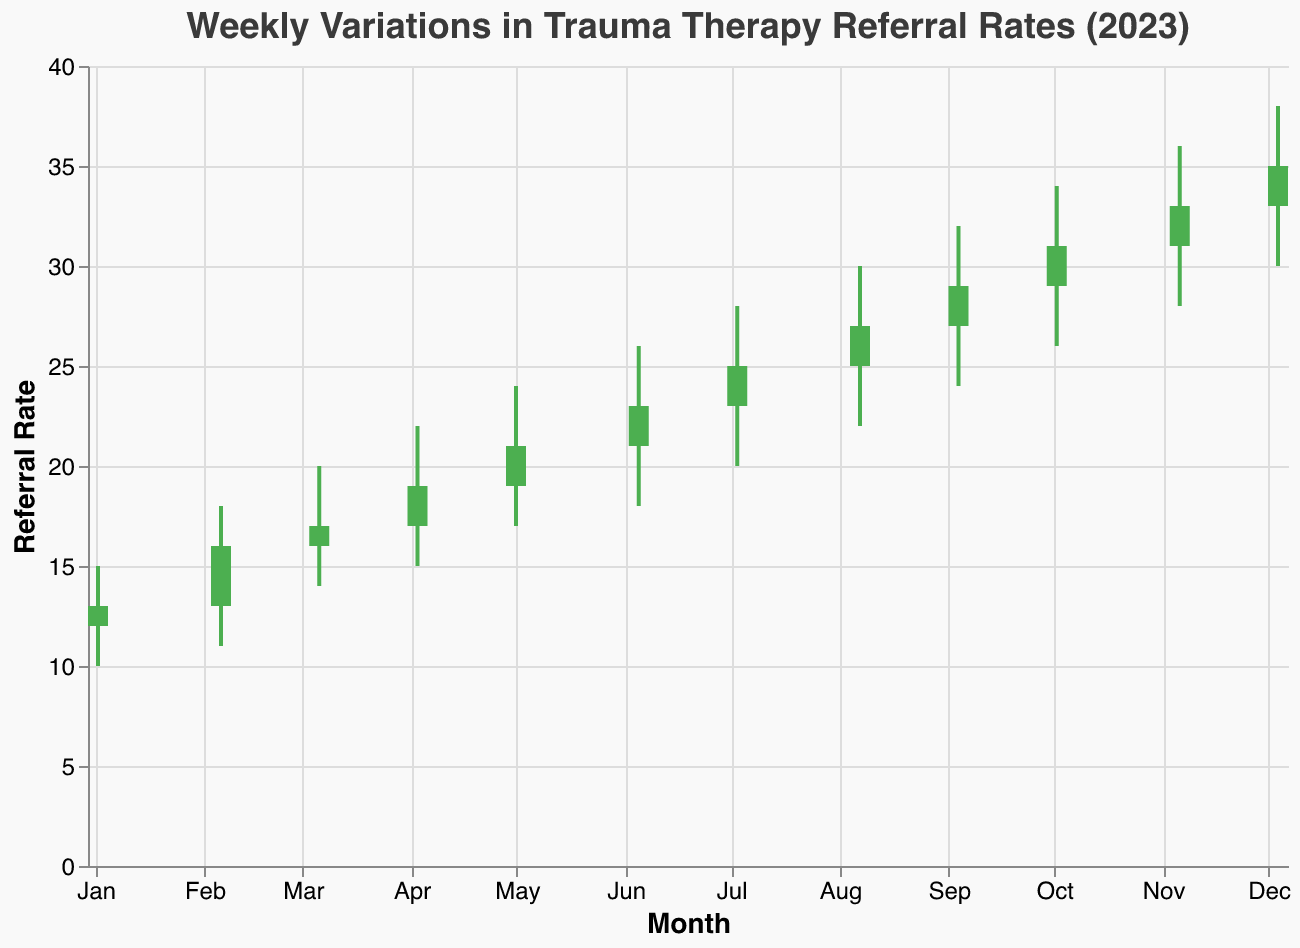What is the highest referral rate recorded in 2023? Look at the "High" values in the chart, the highest value is 38 recorded in December.
Answer: 38 How many weeks had the Close rates higher than the Open rates? Identify the bars colored green, which indicate Close rates greater than Open rates. Count them: from March to December, there are 10 such weeks.
Answer: 10 Which month had the lowest referral rate, and what was that rate? Refer to the "Low" values and identify the lowest, which is 10 recorded in January.
Answer: January, 10 What was the average Open rate for the first half of the year? Sum the Open rates for January to June (12 + 13 + 16 + 17 + 19 + 21) and divide by 6. (12+13+16+17+19+21)/6 = 98/6 ≈ 16.33
Answer: 16.33 By how much did the Close rate increase from January to December? Subtract the Close rate in January (13) from the Close rate in December (35). 35 - 13 = 22
Answer: 22 In which month was the difference between the High and Low values the greatest? Calculate the differences for each month and see which is largest: In December, it's (38-30) = 8.
Answer: December How much did the referral rate fluctuate in August? Look at the August values, the fluctuation is the difference between the High and Low, which is 30 - 22 = 8.
Answer: 8 Which month had the highest increase in Close rate compared to the previous month? Calculate the difference in Close rates between consecutive months: November had the highest increase (33 - 31 = 2).
Answer: November What is the trend of the referral rates throughout the year? Observe the direction of the trend: it shows a consistent upward trend from January to December.
Answer: Upward trend 